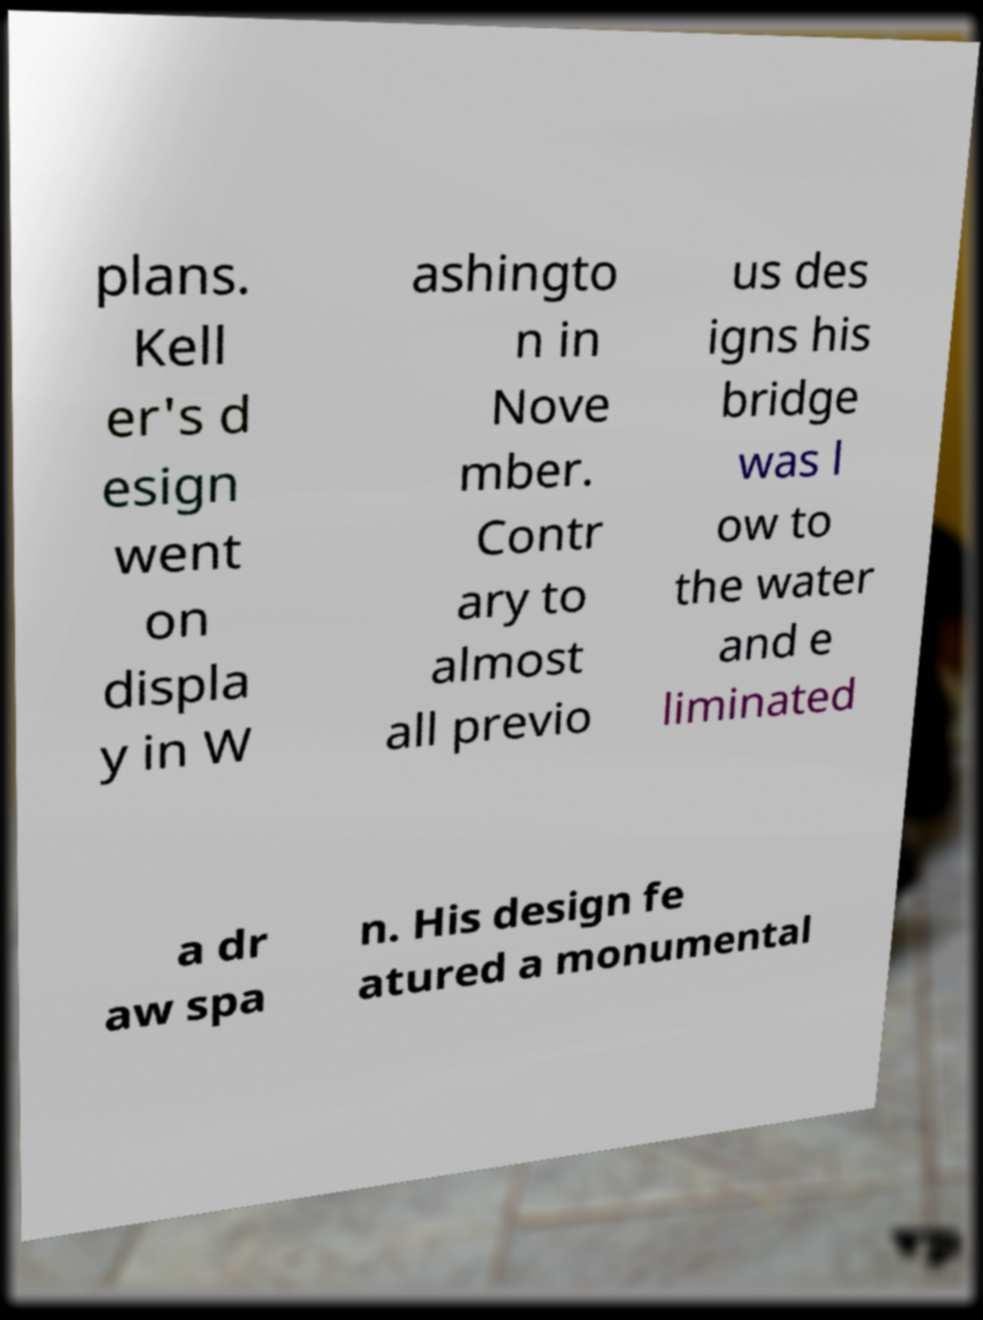Can you read and provide the text displayed in the image?This photo seems to have some interesting text. Can you extract and type it out for me? plans. Kell er's d esign went on displa y in W ashingto n in Nove mber. Contr ary to almost all previo us des igns his bridge was l ow to the water and e liminated a dr aw spa n. His design fe atured a monumental 